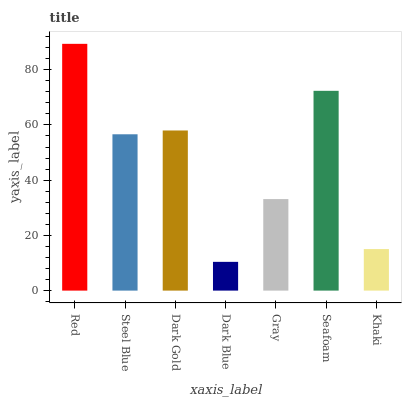Is Dark Blue the minimum?
Answer yes or no. Yes. Is Red the maximum?
Answer yes or no. Yes. Is Steel Blue the minimum?
Answer yes or no. No. Is Steel Blue the maximum?
Answer yes or no. No. Is Red greater than Steel Blue?
Answer yes or no. Yes. Is Steel Blue less than Red?
Answer yes or no. Yes. Is Steel Blue greater than Red?
Answer yes or no. No. Is Red less than Steel Blue?
Answer yes or no. No. Is Steel Blue the high median?
Answer yes or no. Yes. Is Steel Blue the low median?
Answer yes or no. Yes. Is Dark Blue the high median?
Answer yes or no. No. Is Dark Blue the low median?
Answer yes or no. No. 